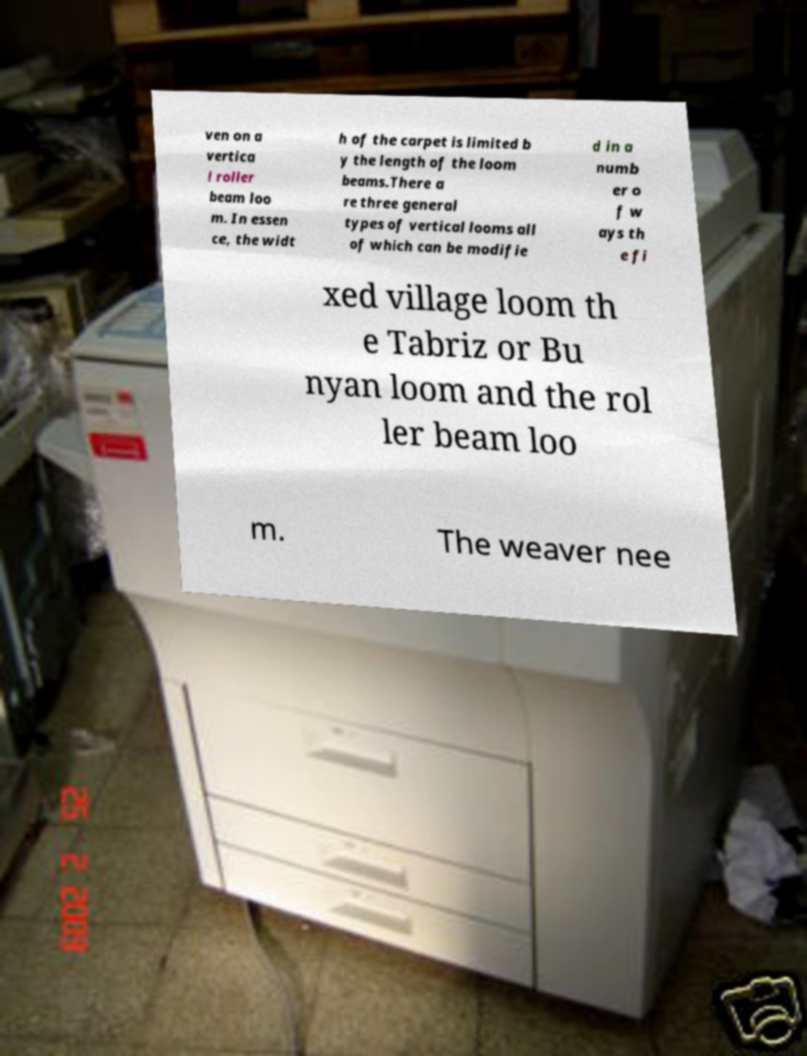Could you assist in decoding the text presented in this image and type it out clearly? ven on a vertica l roller beam loo m. In essen ce, the widt h of the carpet is limited b y the length of the loom beams.There a re three general types of vertical looms all of which can be modifie d in a numb er o f w ays th e fi xed village loom th e Tabriz or Bu nyan loom and the rol ler beam loo m. The weaver nee 